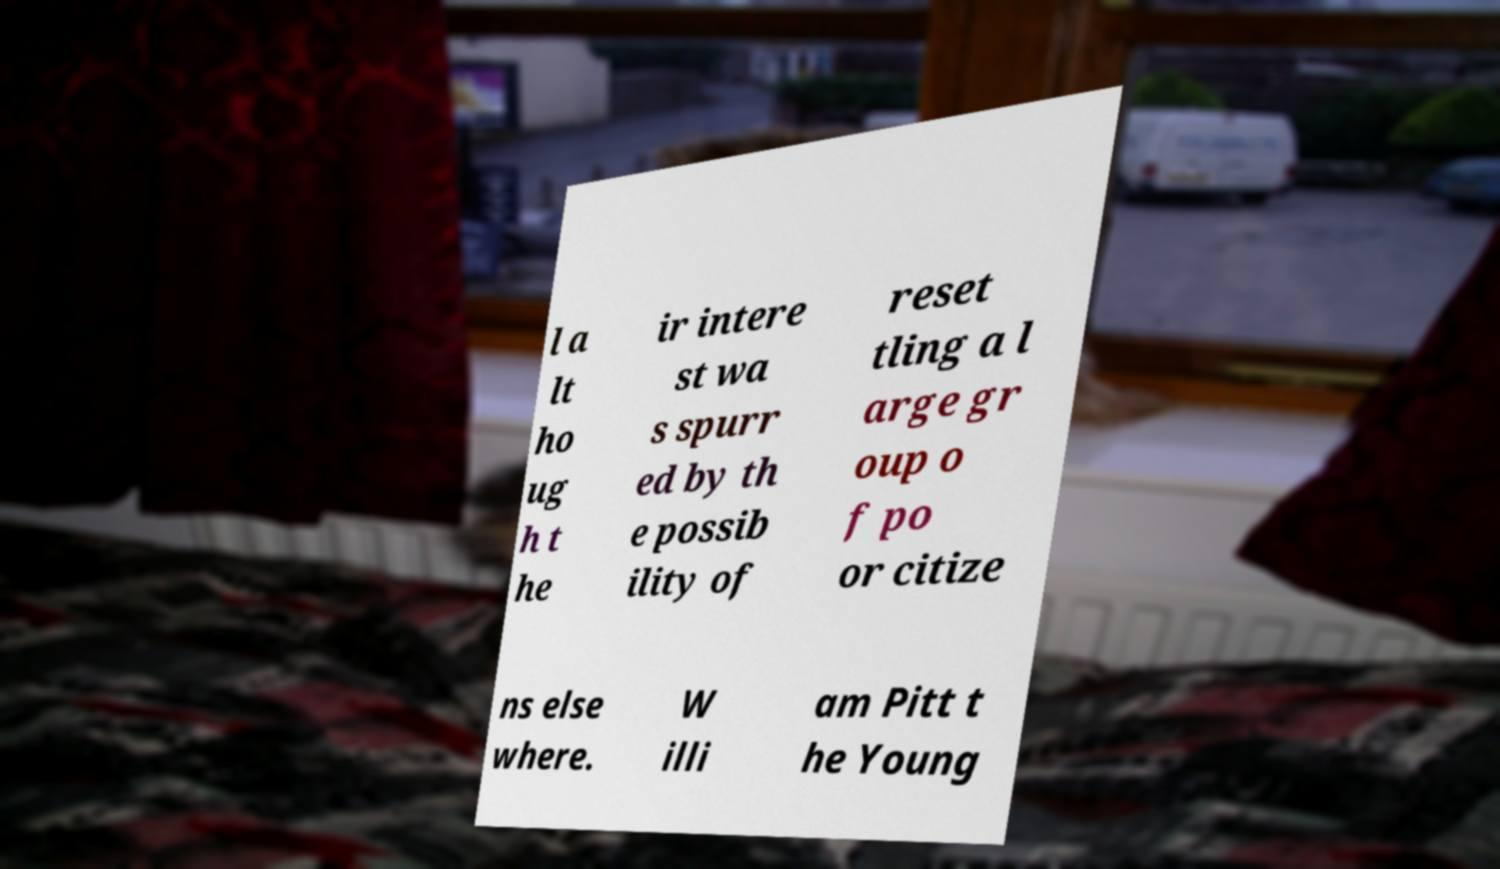Can you accurately transcribe the text from the provided image for me? l a lt ho ug h t he ir intere st wa s spurr ed by th e possib ility of reset tling a l arge gr oup o f po or citize ns else where. W illi am Pitt t he Young 